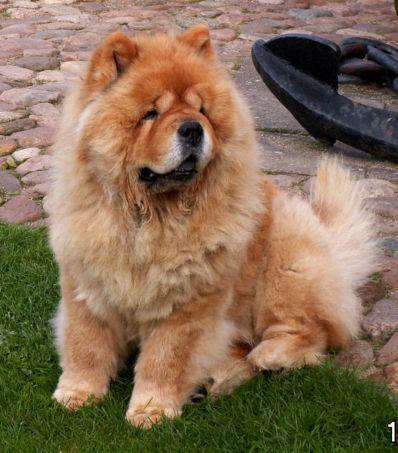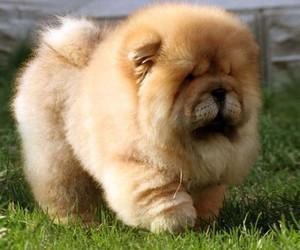The first image is the image on the left, the second image is the image on the right. Analyze the images presented: Is the assertion "There are two dogs shown in total." valid? Answer yes or no. Yes. The first image is the image on the left, the second image is the image on the right. Analyze the images presented: Is the assertion "At least three dogs are shown, with only one in a grassy area." valid? Answer yes or no. No. 